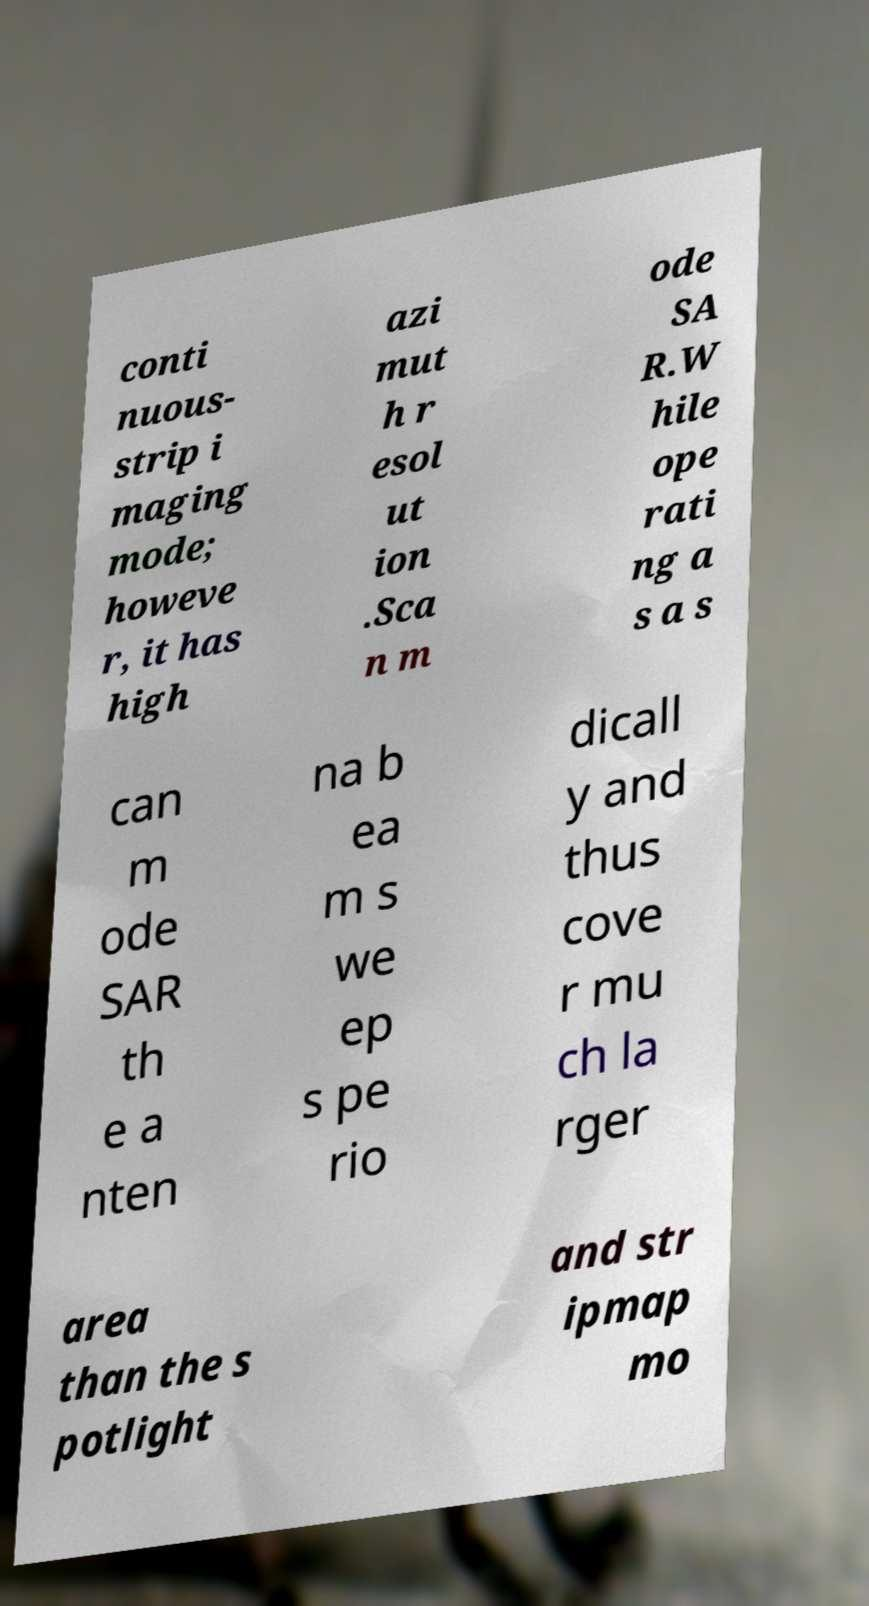What messages or text are displayed in this image? I need them in a readable, typed format. conti nuous- strip i maging mode; howeve r, it has high azi mut h r esol ut ion .Sca n m ode SA R.W hile ope rati ng a s a s can m ode SAR th e a nten na b ea m s we ep s pe rio dicall y and thus cove r mu ch la rger area than the s potlight and str ipmap mo 